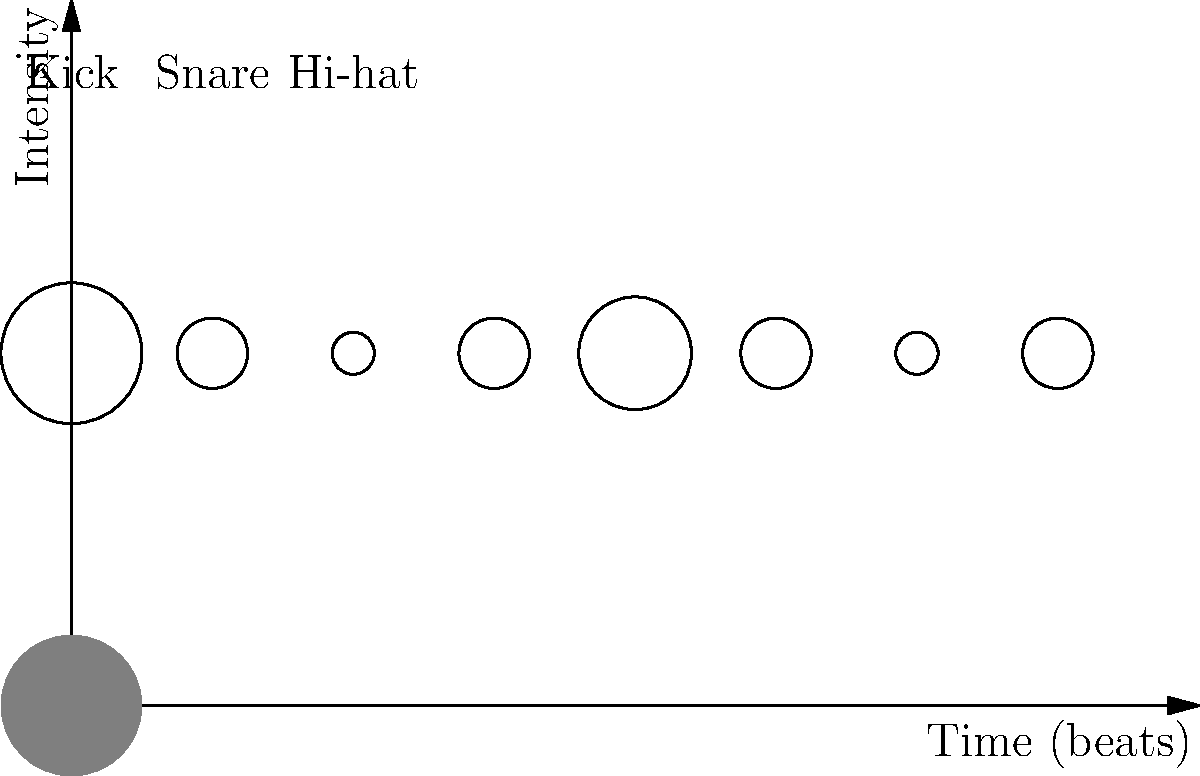As a veteran of the Chinese rock scene, you're helping a young drummer understand rhythm patterns. Given the visual representation of a drum pattern above, determine the tempo in beats per minute (BPM) and the time signature. Assume each beat is represented by a vertical line and the pattern repeats. Let's break this down step-by-step:

1. Count the beats: There are 8 distinct beats shown in the pattern.

2. Identify the time signature:
   - The strongest beat (largest circle) is on the first beat.
   - The second strongest beat (medium-sized circle) is on the 5th beat.
   - This suggests a 4/4 time signature, as it divides the 8 beats into two groups of 4.

3. Determine the tempo:
   - In rock music, tempos typically range from 60 to 160 BPM.
   - Assuming this is a standard rock beat, we can estimate that each beat represents a quarter note.
   - A common tempo for rock music is 120 BPM.

4. Verify the pattern:
   - In a typical rock beat at 120 BPM:
     * Kick drum (1st and 5th beat): $\frac{120 \text{ BPM}}{60 \text{ seconds}} = 2 \text{ beats per second}$
     * Snare drum (3rd and 7th beat): Half as frequent as the kick
     * Hi-hat (all beats): Consistent throughout

   This matches the pattern shown in the image.

Therefore, the most likely tempo is 120 BPM with a 4/4 time signature.
Answer: 120 BPM, 4/4 time signature 